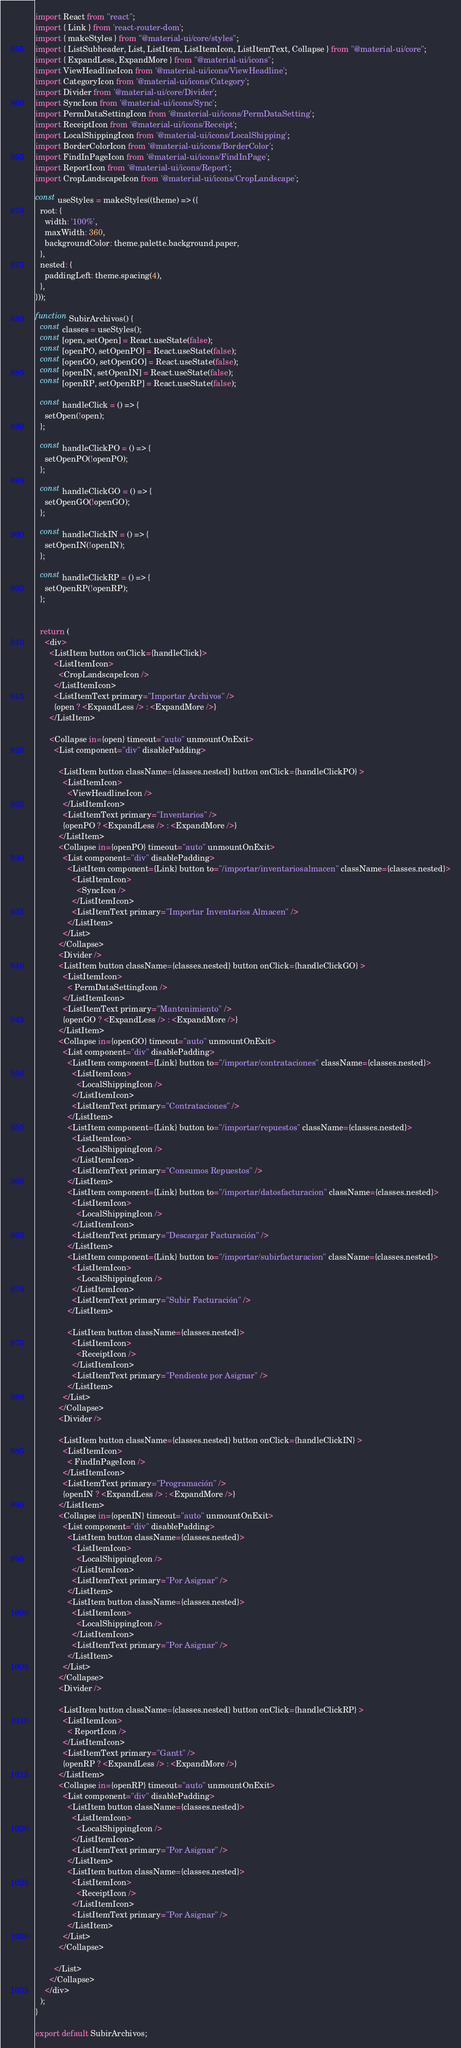<code> <loc_0><loc_0><loc_500><loc_500><_JavaScript_>import React from "react";
import { Link } from 'react-router-dom';
import { makeStyles } from "@material-ui/core/styles";
import { ListSubheader, List, ListItem, ListItemIcon, ListItemText, Collapse } from "@material-ui/core";
import { ExpandLess, ExpandMore } from "@material-ui/icons";
import ViewHeadlineIcon from '@material-ui/icons/ViewHeadline';
import CategoryIcon from '@material-ui/icons/Category';
import Divider from '@material-ui/core/Divider';
import SyncIcon from '@material-ui/icons/Sync';
import PermDataSettingIcon from '@material-ui/icons/PermDataSetting';
import ReceiptIcon from '@material-ui/icons/Receipt';
import LocalShippingIcon from '@material-ui/icons/LocalShipping';
import BorderColorIcon from '@material-ui/icons/BorderColor';
import FindInPageIcon from '@material-ui/icons/FindInPage';
import ReportIcon from '@material-ui/icons/Report';
import CropLandscapeIcon from '@material-ui/icons/CropLandscape';

const useStyles = makeStyles((theme) => ({
  root: {
    width: '100%',
    maxWidth: 360,
    backgroundColor: theme.palette.background.paper,
  },
  nested: {
    paddingLeft: theme.spacing(4),
  },
}));

function SubirArchivos() {
  const classes = useStyles();
  const [open, setOpen] = React.useState(false);
  const [openPO, setOpenPO] = React.useState(false);
  const [openGO, setOpenGO] = React.useState(false);
  const [openIN, setOpenIN] = React.useState(false);
  const [openRP, setOpenRP] = React.useState(false);

  const handleClick = () => {
    setOpen(!open);
  };

  const handleClickPO = () => {
    setOpenPO(!openPO);
  };

  const handleClickGO = () => {
    setOpenGO(!openGO);
  };

  const handleClickIN = () => {
    setOpenIN(!openIN);
  };

  const handleClickRP = () => {
    setOpenRP(!openRP);
  };


  return (
    <div>
      <ListItem button onClick={handleClick}>
        <ListItemIcon>
          <CropLandscapeIcon />
        </ListItemIcon>
        <ListItemText primary="Importar Archivos" />
        {open ? <ExpandLess /> : <ExpandMore />}
      </ListItem>

      <Collapse in={open} timeout="auto" unmountOnExit>
        <List component="div" disablePadding>

          <ListItem button className={classes.nested} button onClick={handleClickPO} >
            <ListItemIcon>
              <ViewHeadlineIcon />
            </ListItemIcon>
            <ListItemText primary="Inventarios" />
            {openPO ? <ExpandLess /> : <ExpandMore />}
          </ListItem>
          <Collapse in={openPO} timeout="auto" unmountOnExit>
            <List component="div" disablePadding>
              <ListItem component={Link} button to="/importar/inventariosalmacen" className={classes.nested}>
                <ListItemIcon>
                  <SyncIcon />
                </ListItemIcon>
                <ListItemText primary="Importar Inventarios Almacen" />
              </ListItem>
            </List>
          </Collapse>
          <Divider />
          <ListItem button className={classes.nested} button onClick={handleClickGO} >
            <ListItemIcon>
              < PermDataSettingIcon />
            </ListItemIcon>
            <ListItemText primary="Mantenimiento" />
            {openGO ? <ExpandLess /> : <ExpandMore />}
          </ListItem>
          <Collapse in={openGO} timeout="auto" unmountOnExit>
            <List component="div" disablePadding>
              <ListItem component={Link} button to="/importar/contrataciones" className={classes.nested}>
                <ListItemIcon>
                  <LocalShippingIcon />
                </ListItemIcon>
                <ListItemText primary="Contrataciones" />
              </ListItem>
              <ListItem component={Link} button to="/importar/repuestos" className={classes.nested}>
                <ListItemIcon>
                  <LocalShippingIcon />
                </ListItemIcon>
                <ListItemText primary="Consumos Repuestos" />
              </ListItem>
              <ListItem component={Link} button to="/importar/datosfacturacion" className={classes.nested}>
                <ListItemIcon>
                  <LocalShippingIcon />
                </ListItemIcon>
                <ListItemText primary="Descargar Facturación" />
              </ListItem>
              <ListItem component={Link} button to="/importar/subirfacturacion" className={classes.nested}>
                <ListItemIcon>
                  <LocalShippingIcon />
                </ListItemIcon>
                <ListItemText primary="Subir Facturación" />
              </ListItem>
              
              <ListItem button className={classes.nested}>
                <ListItemIcon>
                  <ReceiptIcon />
                </ListItemIcon>
                <ListItemText primary="Pendiente por Asignar" />
              </ListItem>
            </List>
          </Collapse>
          <Divider />

          <ListItem button className={classes.nested} button onClick={handleClickIN} >
            <ListItemIcon>
              < FindInPageIcon />
            </ListItemIcon>
            <ListItemText primary="Programación" />
            {openIN ? <ExpandLess /> : <ExpandMore />}
          </ListItem>
          <Collapse in={openIN} timeout="auto" unmountOnExit>
            <List component="div" disablePadding>
              <ListItem button className={classes.nested}>
                <ListItemIcon>
                  <LocalShippingIcon />
                </ListItemIcon>
                <ListItemText primary="Por Asignar" />
              </ListItem>
              <ListItem button className={classes.nested}>
                <ListItemIcon>
                  <LocalShippingIcon />
                </ListItemIcon>
                <ListItemText primary="Por Asignar" />
              </ListItem>
            </List>
          </Collapse>
          <Divider />

          <ListItem button className={classes.nested} button onClick={handleClickRP} >
            <ListItemIcon>
              < ReportIcon />
            </ListItemIcon>
            <ListItemText primary="Gantt" />
            {openRP ? <ExpandLess /> : <ExpandMore />}
          </ListItem>
          <Collapse in={openRP} timeout="auto" unmountOnExit>
            <List component="div" disablePadding>
              <ListItem button className={classes.nested}>
                <ListItemIcon>
                  <LocalShippingIcon />
                </ListItemIcon>
                <ListItemText primary="Por Asignar" />
              </ListItem>
              <ListItem button className={classes.nested}>
                <ListItemIcon>
                  <ReceiptIcon />
                </ListItemIcon>
                <ListItemText primary="Por Asignar" />
              </ListItem>
            </List>
          </Collapse>

        </List>
      </Collapse>
    </div>
  );
}

export default SubirArchivos;</code> 